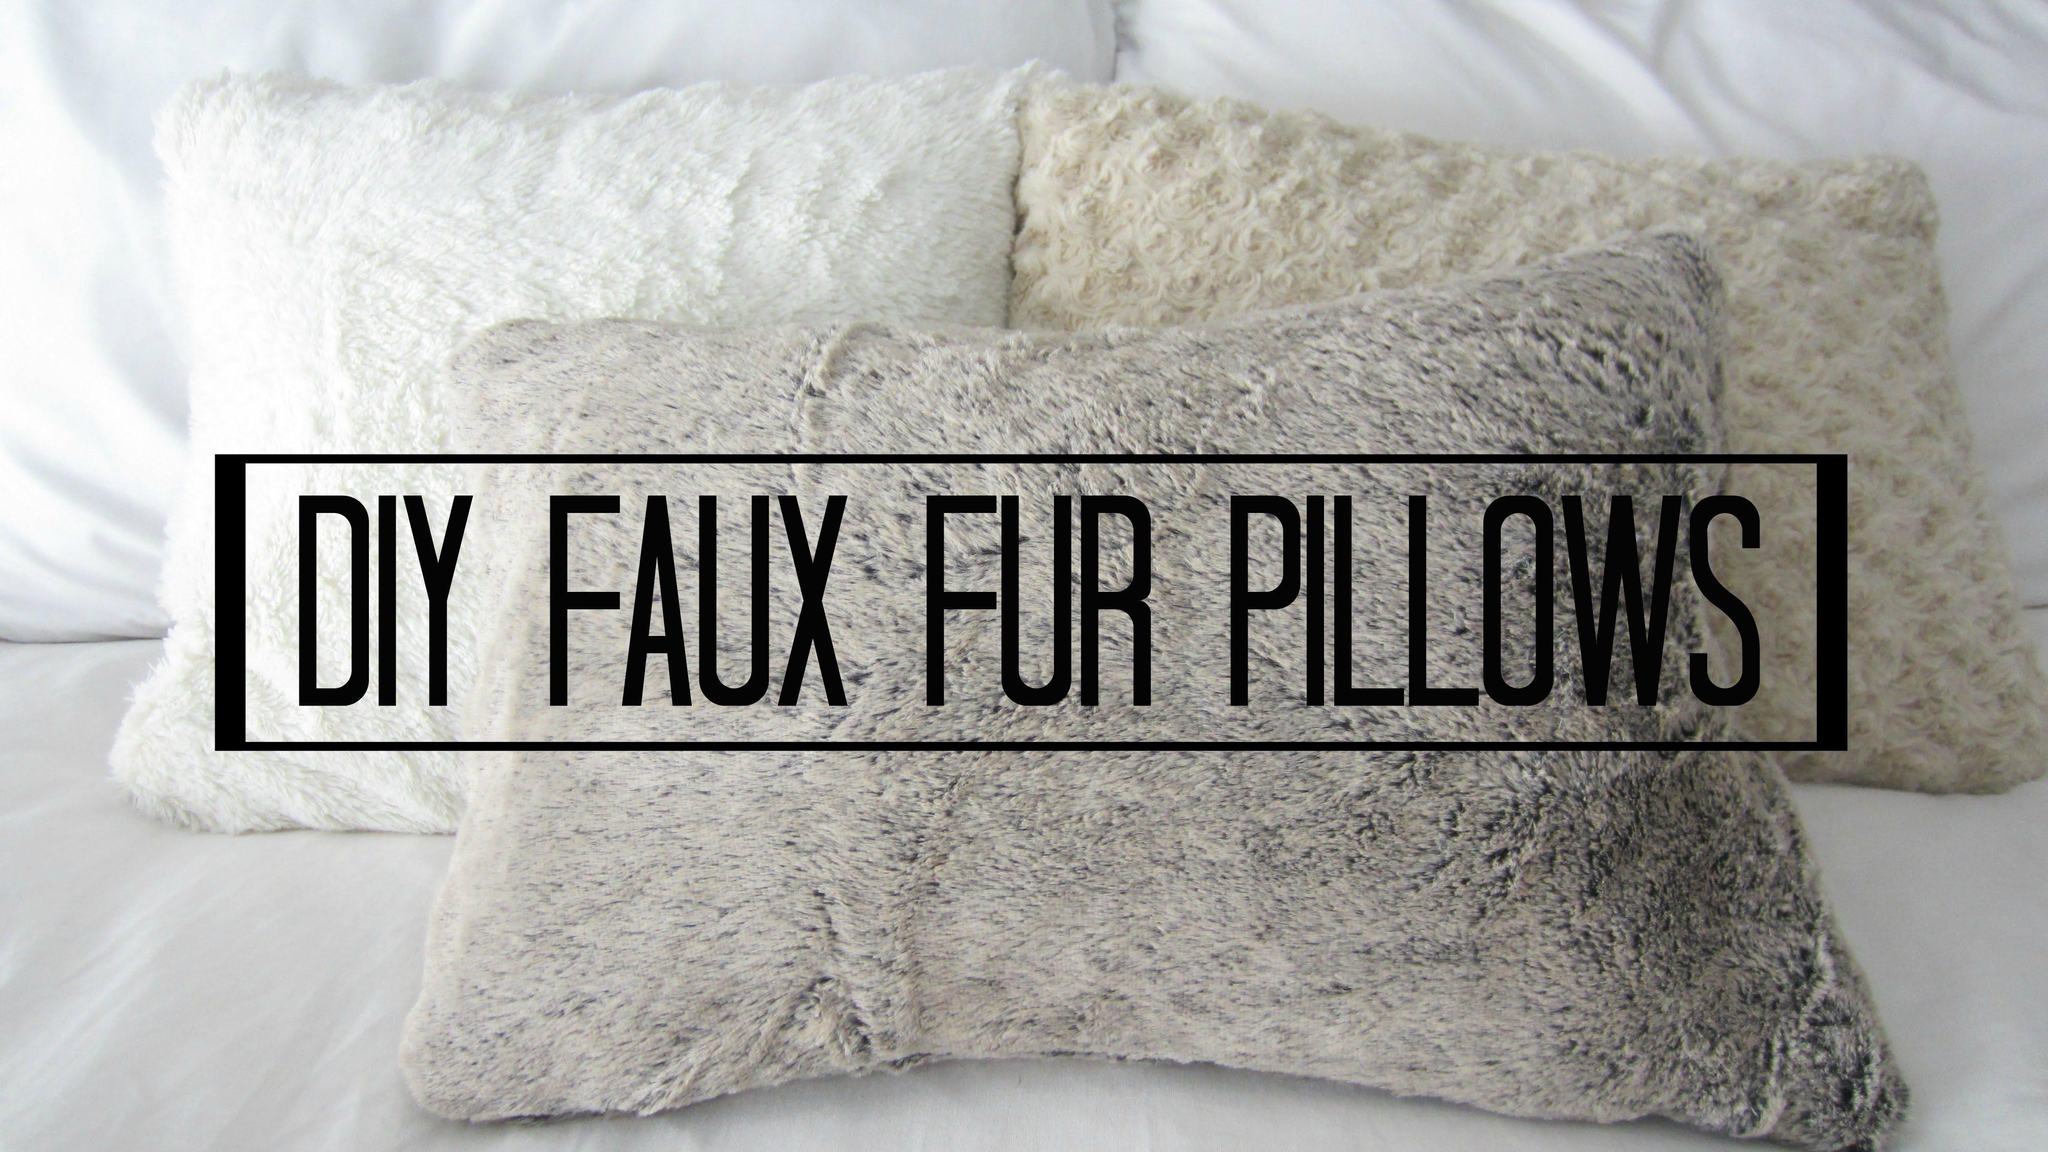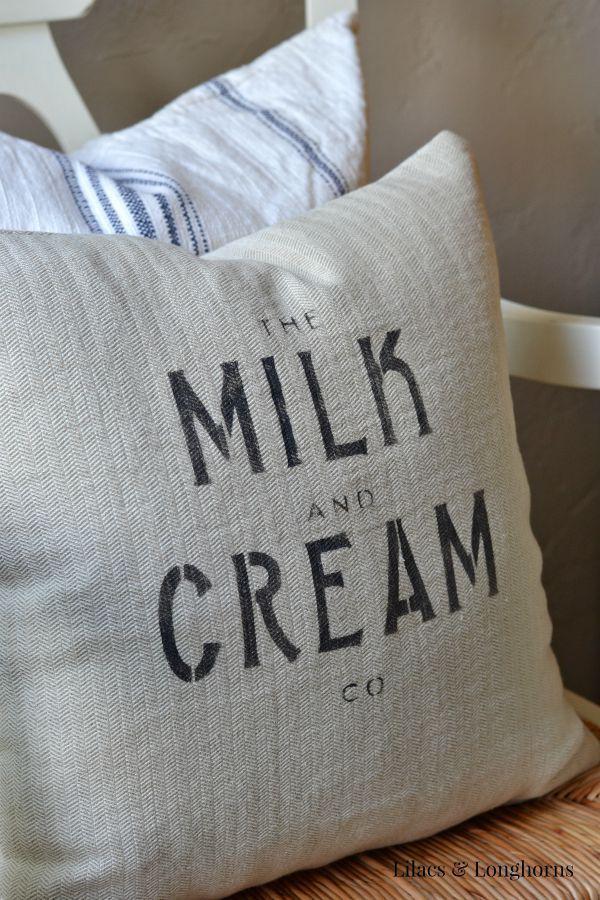The first image is the image on the left, the second image is the image on the right. Analyze the images presented: Is the assertion "There is at least one throw blanket under at least one pillow." valid? Answer yes or no. No. The first image is the image on the left, the second image is the image on the right. Analyze the images presented: Is the assertion "Two pillows with writing on them." valid? Answer yes or no. No. 